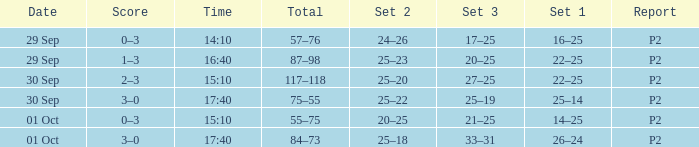What Score has a time of 14:10? 0–3. 